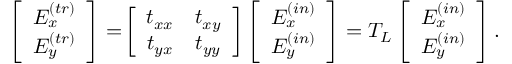Convert formula to latex. <formula><loc_0><loc_0><loc_500><loc_500>\begin{array} { r } { \left [ \begin{array} { c c } { E _ { x } ^ { ( t r ) } } \\ { E _ { y } ^ { ( t r ) } } \end{array} \right ] = \, \left [ \begin{array} { c c } { t _ { x x } } & { t _ { x y } } \\ { t _ { y x } } & { t _ { y y } } \end{array} \right ] \left [ \begin{array} { c c } { E _ { x } ^ { ( i n ) } } \\ { E _ { y } ^ { ( i n ) } } \end{array} \right ] = T _ { L } \left [ \begin{array} { c c } { E _ { x } ^ { ( i n ) } } \\ { E _ { y } ^ { ( i n ) } } \end{array} \right ] . } \end{array}</formula> 